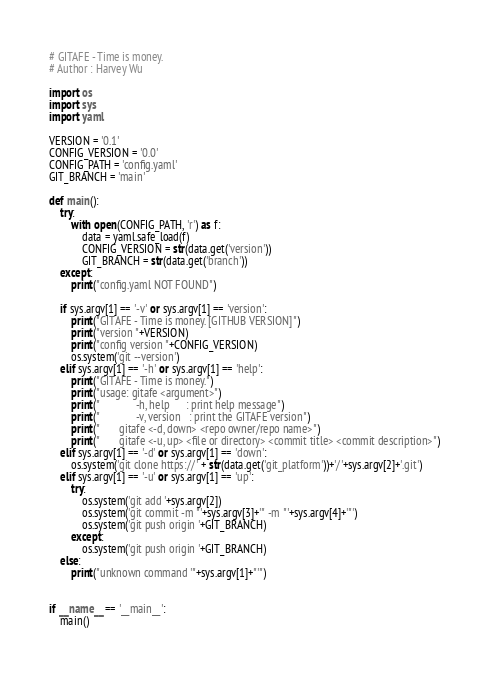Convert code to text. <code><loc_0><loc_0><loc_500><loc_500><_Python_># GITAFE - Time is money.
# Author : Harvey Wu

import os
import sys
import yaml

VERSION = '0.1'
CONFIG_VERSION = '0.0'
CONFIG_PATH = 'config.yaml'
GIT_BRANCH = 'main'

def main():
    try:
        with open(CONFIG_PATH, 'r') as f:
            data = yaml.safe_load(f)
            CONFIG_VERSION = str(data.get('version'))
            GIT_BRANCH = str(data.get('branch'))
    except:
        print("config.yaml NOT FOUND")

    if sys.argv[1] == '-v' or sys.argv[1] == 'version':
        print("GITAFE - Time is money. [GITHUB VERSION]")
        print("version "+VERSION)
        print("config version "+CONFIG_VERSION)
        os.system('git --version')
    elif sys.argv[1] == '-h' or sys.argv[1] == 'help':
        print("GITAFE - Time is money.")
        print("usage: gitafe <argument>")
        print("             -h, help      : print help message")
        print("             -v, version   : print the GITAFE version")
        print("       gitafe <-d, down> <repo owner/repo name>")
        print("       gitafe <-u, up> <file or directory> <commit title> <commit description>")
    elif sys.argv[1] == '-d' or sys.argv[1] == 'down':
        os.system('git clone https://' + str(data.get('git_platform'))+'/'+sys.argv[2]+'.git')
    elif sys.argv[1] == '-u' or sys.argv[1] == 'up':
        try:
            os.system('git add '+sys.argv[2])
            os.system('git commit -m "'+sys.argv[3]+'" -m "'+sys.argv[4]+'"')
            os.system('git push origin '+GIT_BRANCH)
        except:
            os.system('git push origin '+GIT_BRANCH)
    else:
        print("unknown command '"+sys.argv[1]+"'")


if __name__ == '__main__':
    main()
</code> 